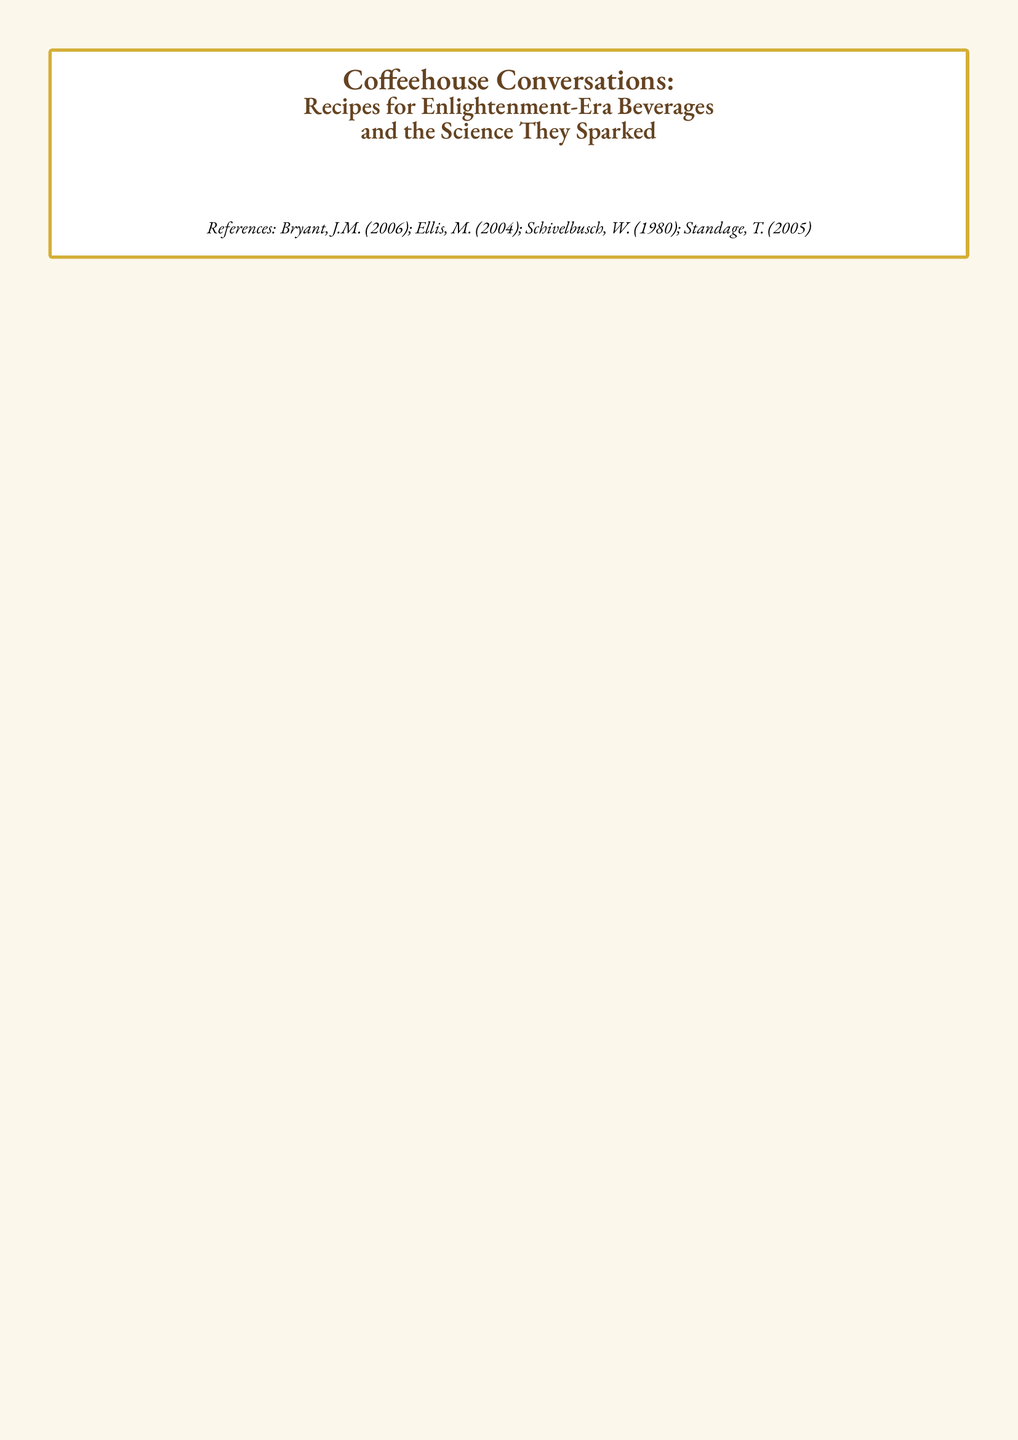What is the title of the recipe card? The title is located at the top of the document, summarizing its content on beverages and science during the Enlightenment.
Answer: Coffeehouse Conversations: Recipes for Enlightenment-Era Beverages and the Science They Sparked How many ingredients are in the Turkish Coffee recipe? The ingredients list for Turkish Coffee details four items necessary to prepare the drink.
Answer: 4 What ingredient is optional in the English Coffee recipe? The ingredients for English Coffee mention a specific item that can be omitted based on personal preference.
Answer: molasses Which philosopher is mentioned in relation to French Café au Lait? The historical context of the recipe references specific influential figures from the Enlightenment when discussing philosophical ideas in coffeehouses.
Answer: Voltaire What was a common topic of discussion in Viennese coffeehouses? The historical context associated with Viennese Melange highlights the discussions that occurred regarding scientific advancements in various fields.
Answer: chemistry What is the cooling mechanism for the foam in Turkish Coffee? The instructions detail the process used in preparing Turkish Coffee, specifically the action taken to manage the foam during brewing.
Answer: Lift from heat and let the foam settle What sweetener is suggested for the Turkish Coffee? The recipe includes suggestions for optional enhancements to the flavor profile of Turkish Coffee, which helps to customize the beverage.
Answer: sugar How much coffee is used in the French Café au Lait recipe? The French Café au Lait recipe specifies the amount of brewed coffee required to create the drink.
Answer: 2 cups What are the two spices used in the English Coffee recipe? The instructions in the English Coffee recipe mention particular spices that contribute to its flavor.
Answer: nutmeg, cinnamon 